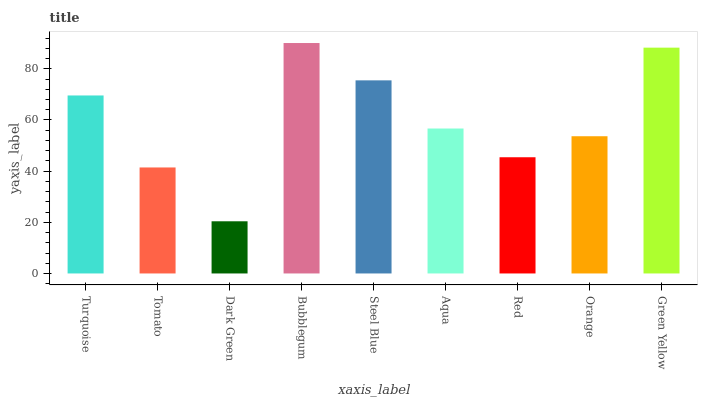Is Dark Green the minimum?
Answer yes or no. Yes. Is Bubblegum the maximum?
Answer yes or no. Yes. Is Tomato the minimum?
Answer yes or no. No. Is Tomato the maximum?
Answer yes or no. No. Is Turquoise greater than Tomato?
Answer yes or no. Yes. Is Tomato less than Turquoise?
Answer yes or no. Yes. Is Tomato greater than Turquoise?
Answer yes or no. No. Is Turquoise less than Tomato?
Answer yes or no. No. Is Aqua the high median?
Answer yes or no. Yes. Is Aqua the low median?
Answer yes or no. Yes. Is Tomato the high median?
Answer yes or no. No. Is Red the low median?
Answer yes or no. No. 